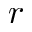Convert formula to latex. <formula><loc_0><loc_0><loc_500><loc_500>r</formula> 